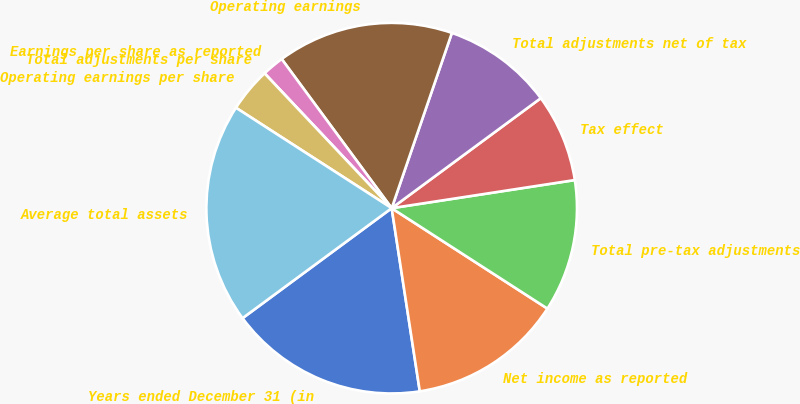<chart> <loc_0><loc_0><loc_500><loc_500><pie_chart><fcel>Years ended December 31 (in<fcel>Net income as reported<fcel>Total pre-tax adjustments<fcel>Tax effect<fcel>Total adjustments net of tax<fcel>Operating earnings<fcel>Earnings per share as reported<fcel>Total adjustments per share<fcel>Operating earnings per share<fcel>Average total assets<nl><fcel>17.31%<fcel>13.46%<fcel>11.54%<fcel>7.69%<fcel>9.62%<fcel>15.38%<fcel>1.92%<fcel>0.0%<fcel>3.85%<fcel>19.23%<nl></chart> 